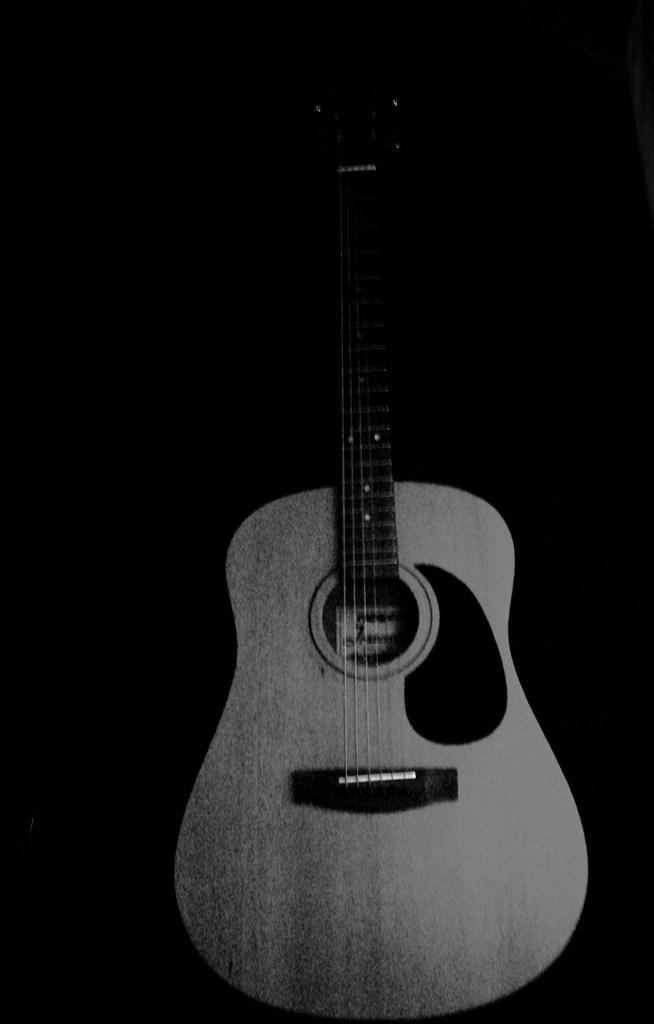Describe this image in one or two sentences. There is a guitar in the image. 